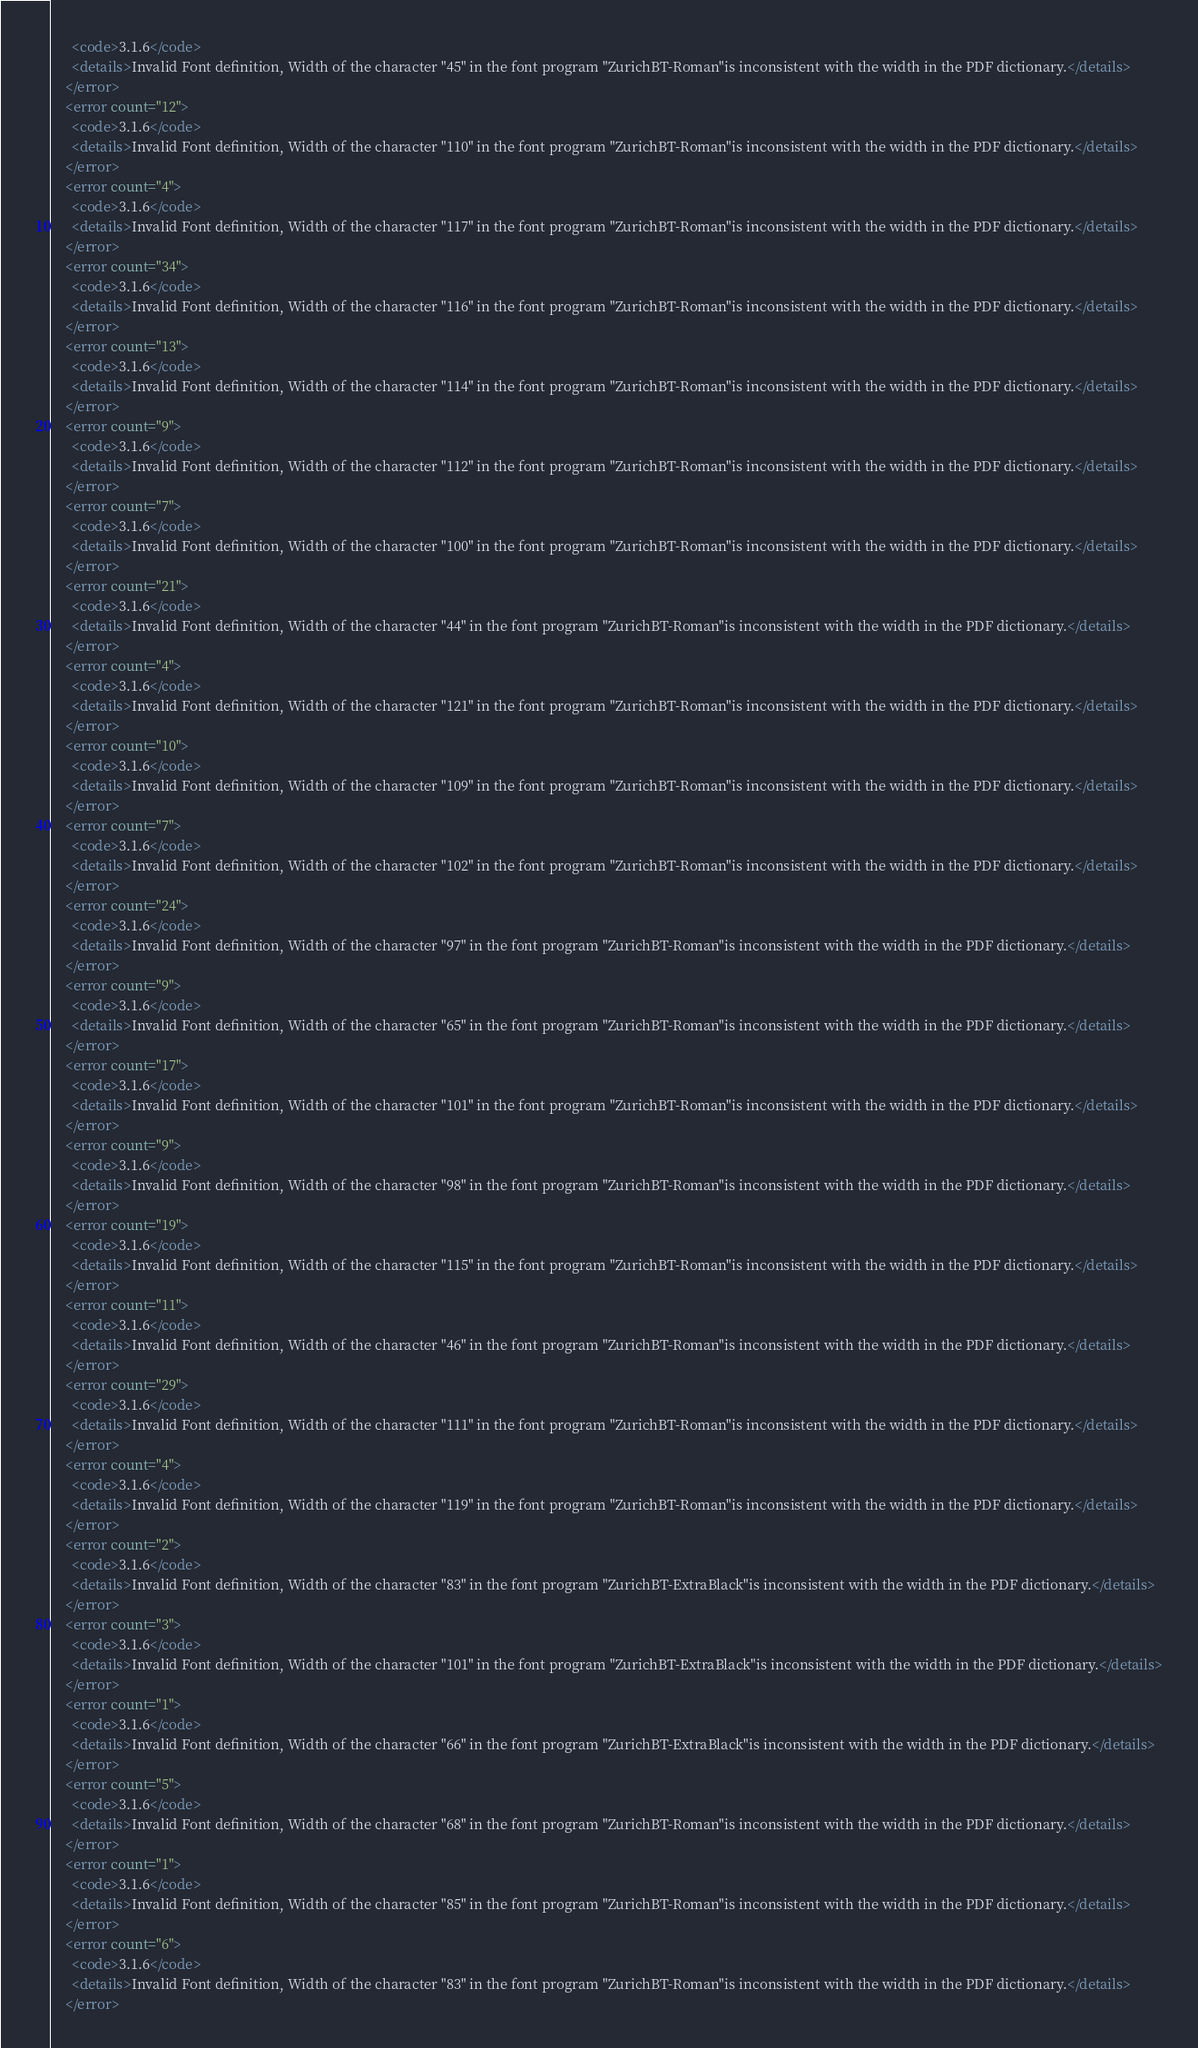Convert code to text. <code><loc_0><loc_0><loc_500><loc_500><_XML_>      <code>3.1.6</code>
      <details>Invalid Font definition, Width of the character "45" in the font program "ZurichBT-Roman"is inconsistent with the width in the PDF dictionary.</details>
    </error>
    <error count="12">
      <code>3.1.6</code>
      <details>Invalid Font definition, Width of the character "110" in the font program "ZurichBT-Roman"is inconsistent with the width in the PDF dictionary.</details>
    </error>
    <error count="4">
      <code>3.1.6</code>
      <details>Invalid Font definition, Width of the character "117" in the font program "ZurichBT-Roman"is inconsistent with the width in the PDF dictionary.</details>
    </error>
    <error count="34">
      <code>3.1.6</code>
      <details>Invalid Font definition, Width of the character "116" in the font program "ZurichBT-Roman"is inconsistent with the width in the PDF dictionary.</details>
    </error>
    <error count="13">
      <code>3.1.6</code>
      <details>Invalid Font definition, Width of the character "114" in the font program "ZurichBT-Roman"is inconsistent with the width in the PDF dictionary.</details>
    </error>
    <error count="9">
      <code>3.1.6</code>
      <details>Invalid Font definition, Width of the character "112" in the font program "ZurichBT-Roman"is inconsistent with the width in the PDF dictionary.</details>
    </error>
    <error count="7">
      <code>3.1.6</code>
      <details>Invalid Font definition, Width of the character "100" in the font program "ZurichBT-Roman"is inconsistent with the width in the PDF dictionary.</details>
    </error>
    <error count="21">
      <code>3.1.6</code>
      <details>Invalid Font definition, Width of the character "44" in the font program "ZurichBT-Roman"is inconsistent with the width in the PDF dictionary.</details>
    </error>
    <error count="4">
      <code>3.1.6</code>
      <details>Invalid Font definition, Width of the character "121" in the font program "ZurichBT-Roman"is inconsistent with the width in the PDF dictionary.</details>
    </error>
    <error count="10">
      <code>3.1.6</code>
      <details>Invalid Font definition, Width of the character "109" in the font program "ZurichBT-Roman"is inconsistent with the width in the PDF dictionary.</details>
    </error>
    <error count="7">
      <code>3.1.6</code>
      <details>Invalid Font definition, Width of the character "102" in the font program "ZurichBT-Roman"is inconsistent with the width in the PDF dictionary.</details>
    </error>
    <error count="24">
      <code>3.1.6</code>
      <details>Invalid Font definition, Width of the character "97" in the font program "ZurichBT-Roman"is inconsistent with the width in the PDF dictionary.</details>
    </error>
    <error count="9">
      <code>3.1.6</code>
      <details>Invalid Font definition, Width of the character "65" in the font program "ZurichBT-Roman"is inconsistent with the width in the PDF dictionary.</details>
    </error>
    <error count="17">
      <code>3.1.6</code>
      <details>Invalid Font definition, Width of the character "101" in the font program "ZurichBT-Roman"is inconsistent with the width in the PDF dictionary.</details>
    </error>
    <error count="9">
      <code>3.1.6</code>
      <details>Invalid Font definition, Width of the character "98" in the font program "ZurichBT-Roman"is inconsistent with the width in the PDF dictionary.</details>
    </error>
    <error count="19">
      <code>3.1.6</code>
      <details>Invalid Font definition, Width of the character "115" in the font program "ZurichBT-Roman"is inconsistent with the width in the PDF dictionary.</details>
    </error>
    <error count="11">
      <code>3.1.6</code>
      <details>Invalid Font definition, Width of the character "46" in the font program "ZurichBT-Roman"is inconsistent with the width in the PDF dictionary.</details>
    </error>
    <error count="29">
      <code>3.1.6</code>
      <details>Invalid Font definition, Width of the character "111" in the font program "ZurichBT-Roman"is inconsistent with the width in the PDF dictionary.</details>
    </error>
    <error count="4">
      <code>3.1.6</code>
      <details>Invalid Font definition, Width of the character "119" in the font program "ZurichBT-Roman"is inconsistent with the width in the PDF dictionary.</details>
    </error>
    <error count="2">
      <code>3.1.6</code>
      <details>Invalid Font definition, Width of the character "83" in the font program "ZurichBT-ExtraBlack"is inconsistent with the width in the PDF dictionary.</details>
    </error>
    <error count="3">
      <code>3.1.6</code>
      <details>Invalid Font definition, Width of the character "101" in the font program "ZurichBT-ExtraBlack"is inconsistent with the width in the PDF dictionary.</details>
    </error>
    <error count="1">
      <code>3.1.6</code>
      <details>Invalid Font definition, Width of the character "66" in the font program "ZurichBT-ExtraBlack"is inconsistent with the width in the PDF dictionary.</details>
    </error>
    <error count="5">
      <code>3.1.6</code>
      <details>Invalid Font definition, Width of the character "68" in the font program "ZurichBT-Roman"is inconsistent with the width in the PDF dictionary.</details>
    </error>
    <error count="1">
      <code>3.1.6</code>
      <details>Invalid Font definition, Width of the character "85" in the font program "ZurichBT-Roman"is inconsistent with the width in the PDF dictionary.</details>
    </error>
    <error count="6">
      <code>3.1.6</code>
      <details>Invalid Font definition, Width of the character "83" in the font program "ZurichBT-Roman"is inconsistent with the width in the PDF dictionary.</details>
    </error></code> 